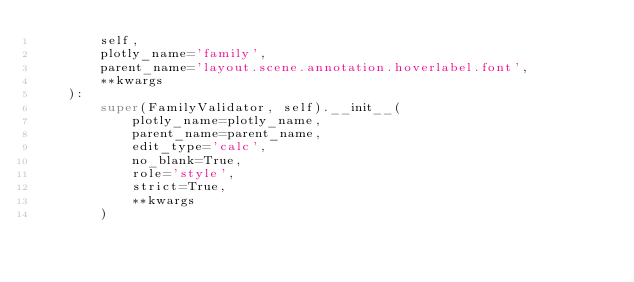<code> <loc_0><loc_0><loc_500><loc_500><_Python_>        self,
        plotly_name='family',
        parent_name='layout.scene.annotation.hoverlabel.font',
        **kwargs
    ):
        super(FamilyValidator, self).__init__(
            plotly_name=plotly_name,
            parent_name=parent_name,
            edit_type='calc',
            no_blank=True,
            role='style',
            strict=True,
            **kwargs
        )
</code> 